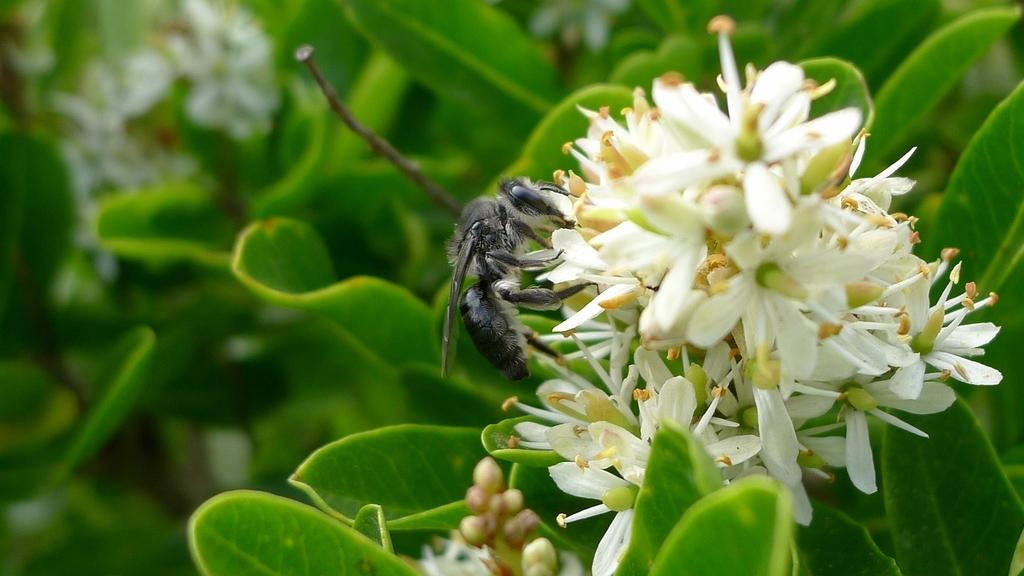What types of living organisms can be seen in the image? Plants and flowers are visible in the image. Are there any other living organisms present in the image? Yes, there is an insect in the image. What type of cheese can be seen in the image? There is no cheese present in the image. What can be used to cut the flowers in the image? There are no scissors or any cutting tools present in the image. 